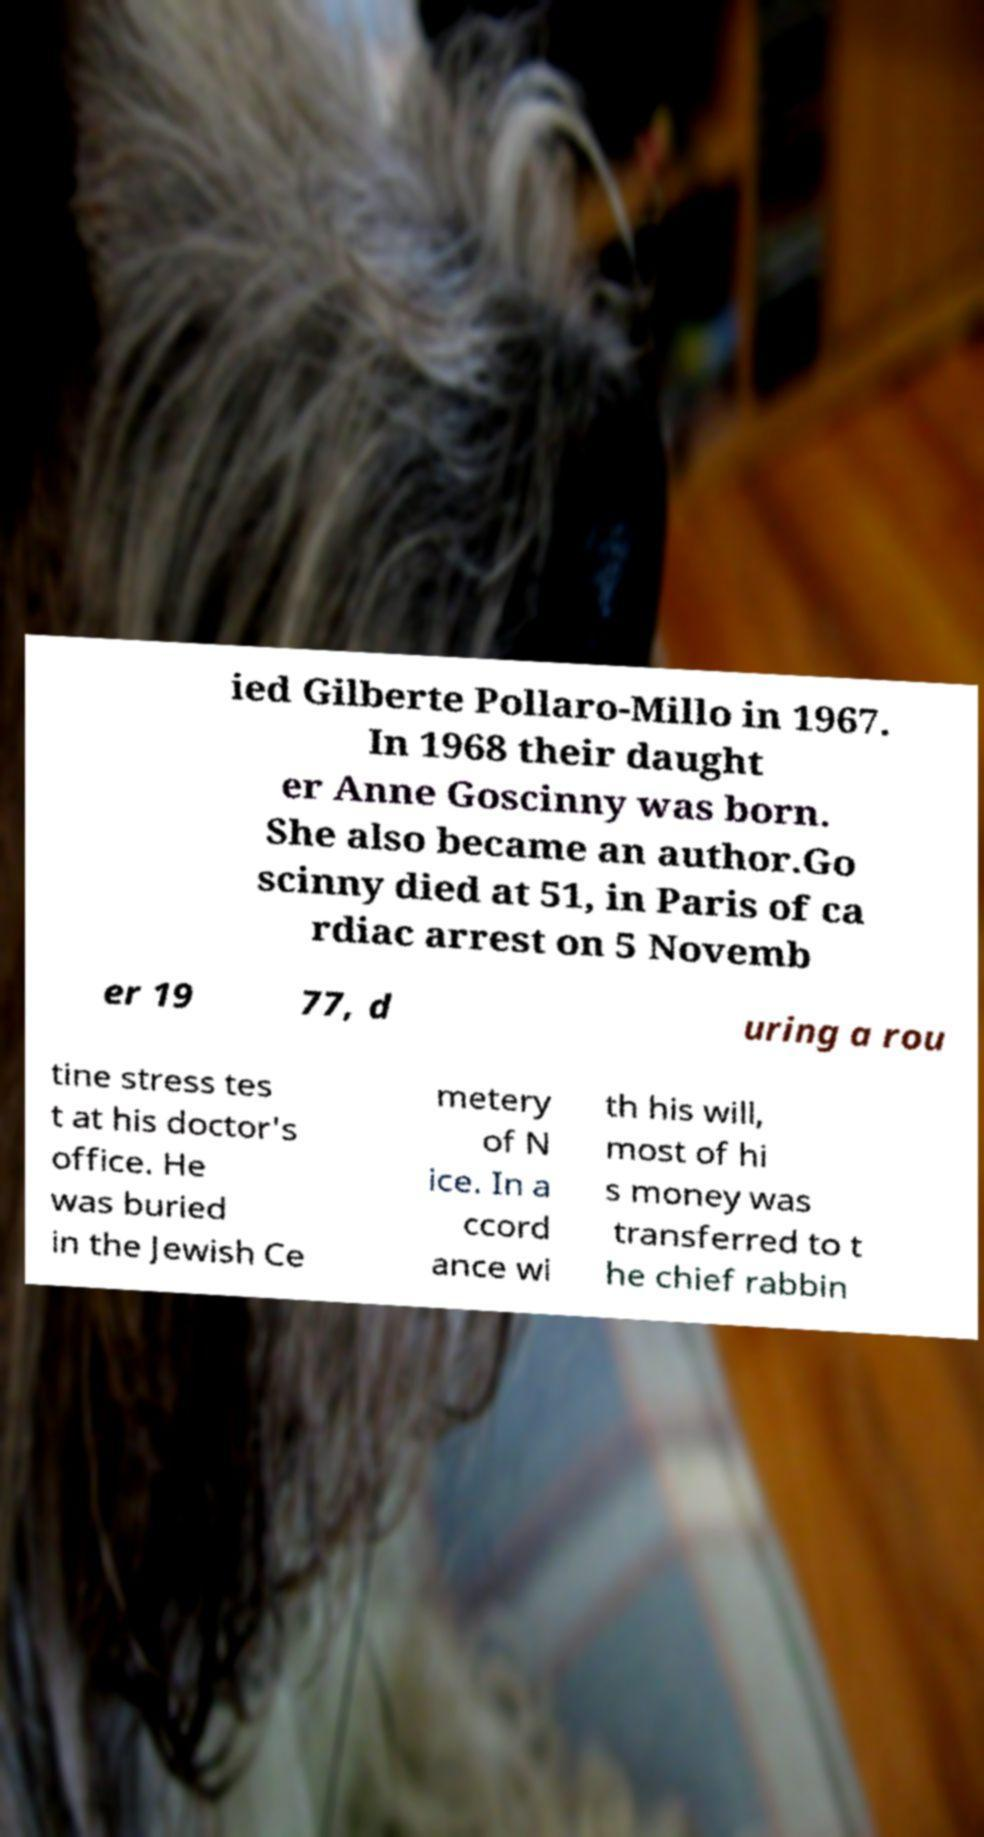Please read and relay the text visible in this image. What does it say? ied Gilberte Pollaro-Millo in 1967. In 1968 their daught er Anne Goscinny was born. She also became an author.Go scinny died at 51, in Paris of ca rdiac arrest on 5 Novemb er 19 77, d uring a rou tine stress tes t at his doctor's office. He was buried in the Jewish Ce metery of N ice. In a ccord ance wi th his will, most of hi s money was transferred to t he chief rabbin 